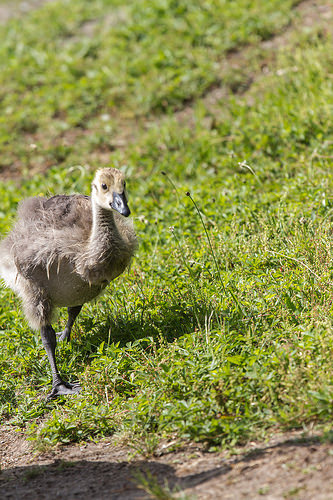<image>
Can you confirm if the hen is on the grass? Yes. Looking at the image, I can see the hen is positioned on top of the grass, with the grass providing support. 